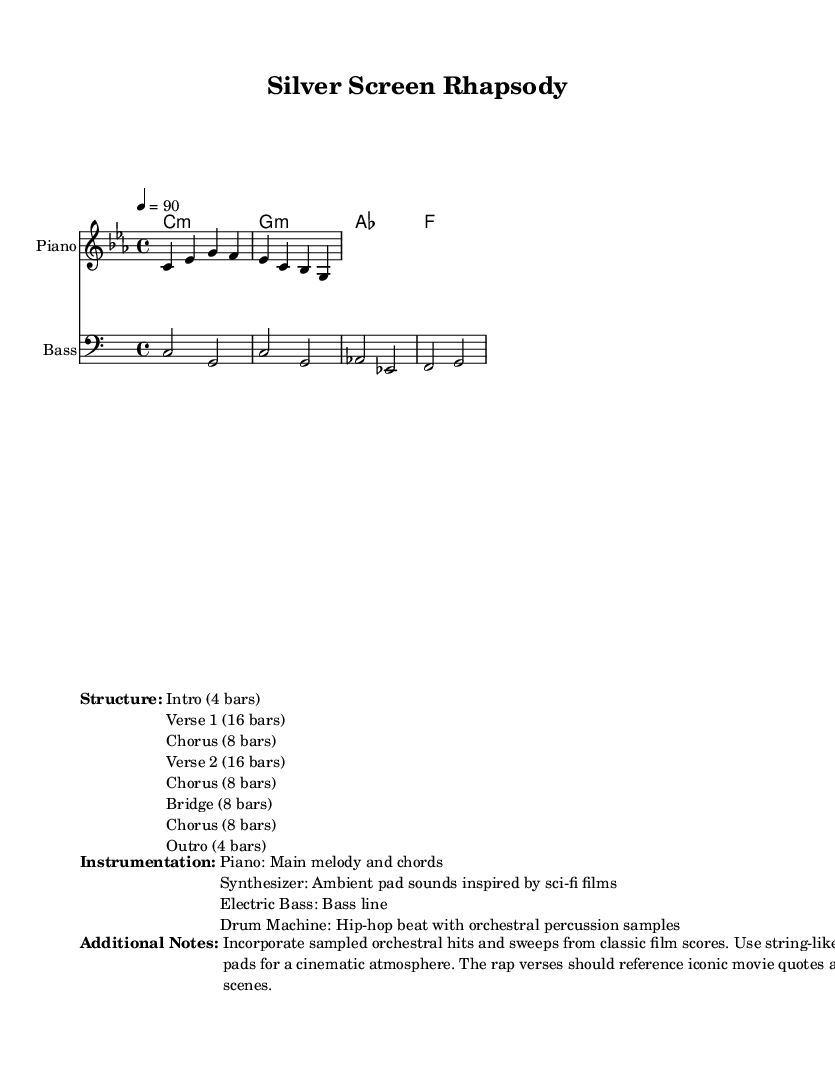What is the time signature of this music? The time signature is specified in the global settings of the score, shown as 4/4. This means there are four beats in each measure, and the quarter note receives one beat.
Answer: 4/4 What key is this piece written in? The key signature is also found in the global settings; it indicates that the piece is in C minor, which has three flats (B, E, and A).
Answer: C minor How many bars are in the Chorus section? The structure section of the score outlines the different sections of the piece. It lists the Chorus section as having 8 bars.
Answer: 8 bars What instrument plays the main melody? The instrumentation section identifies that the Piano plays the main melody as indicated in the staff labeled "Piano."
Answer: Piano How many total bars are in the piece? To find this, we can add up the bars from each section mentioned in the structure: intro (4) + verse 1 (16) + chorus (8) + verse 2 (16) + chorus (8) + bridge (8) + chorus (8) + outro (4) = 72 bars total.
Answer: 72 bars What type of percussion is used in the composition? The instrumentation notes mention that a Drum Machine is used, specifically referencing its hip-hop beat combined with orchestral percussion samples.
Answer: Drum Machine What notable feature does the composition incorporate? The additional notes mention the incorporation of sampled orchestral hits and sweeps from classic film scores, which adds a cinematic element to the rap.
Answer: Sampled orchestral hits 